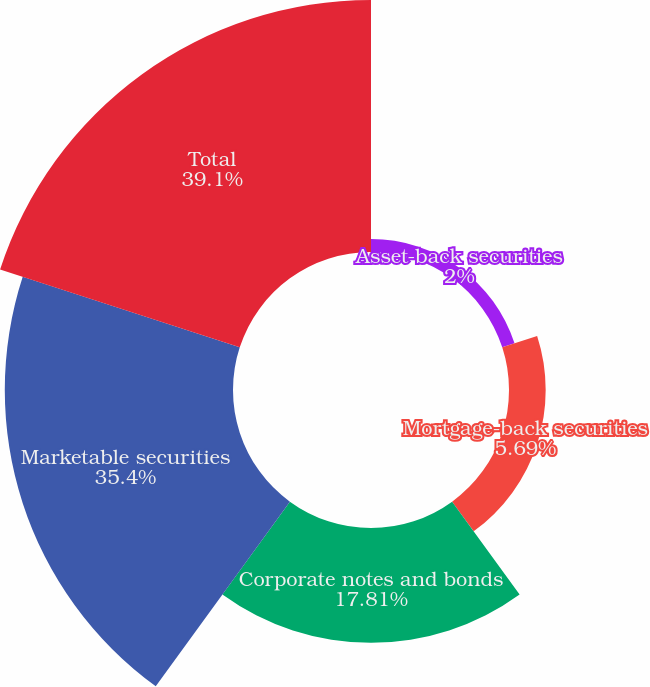<chart> <loc_0><loc_0><loc_500><loc_500><pie_chart><fcel>Asset-back securities<fcel>Mortgage-back securities<fcel>Corporate notes and bonds<fcel>Marketable securities<fcel>Total<nl><fcel>2.0%<fcel>5.69%<fcel>17.81%<fcel>35.4%<fcel>39.09%<nl></chart> 